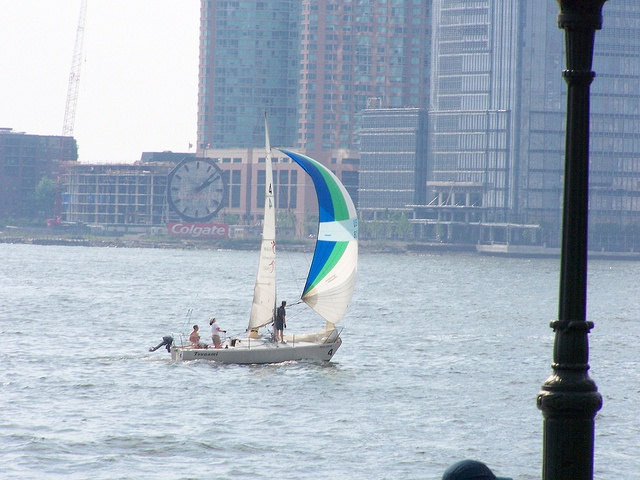Describe the objects in this image and their specific colors. I can see boat in white, lightgray, darkgray, and gray tones, clock in white, darkgray, and gray tones, people in white, gray, black, darkblue, and darkgray tones, people in white, darkgray, gray, and lightgray tones, and people in white, gray, darkgray, and lightgray tones in this image. 